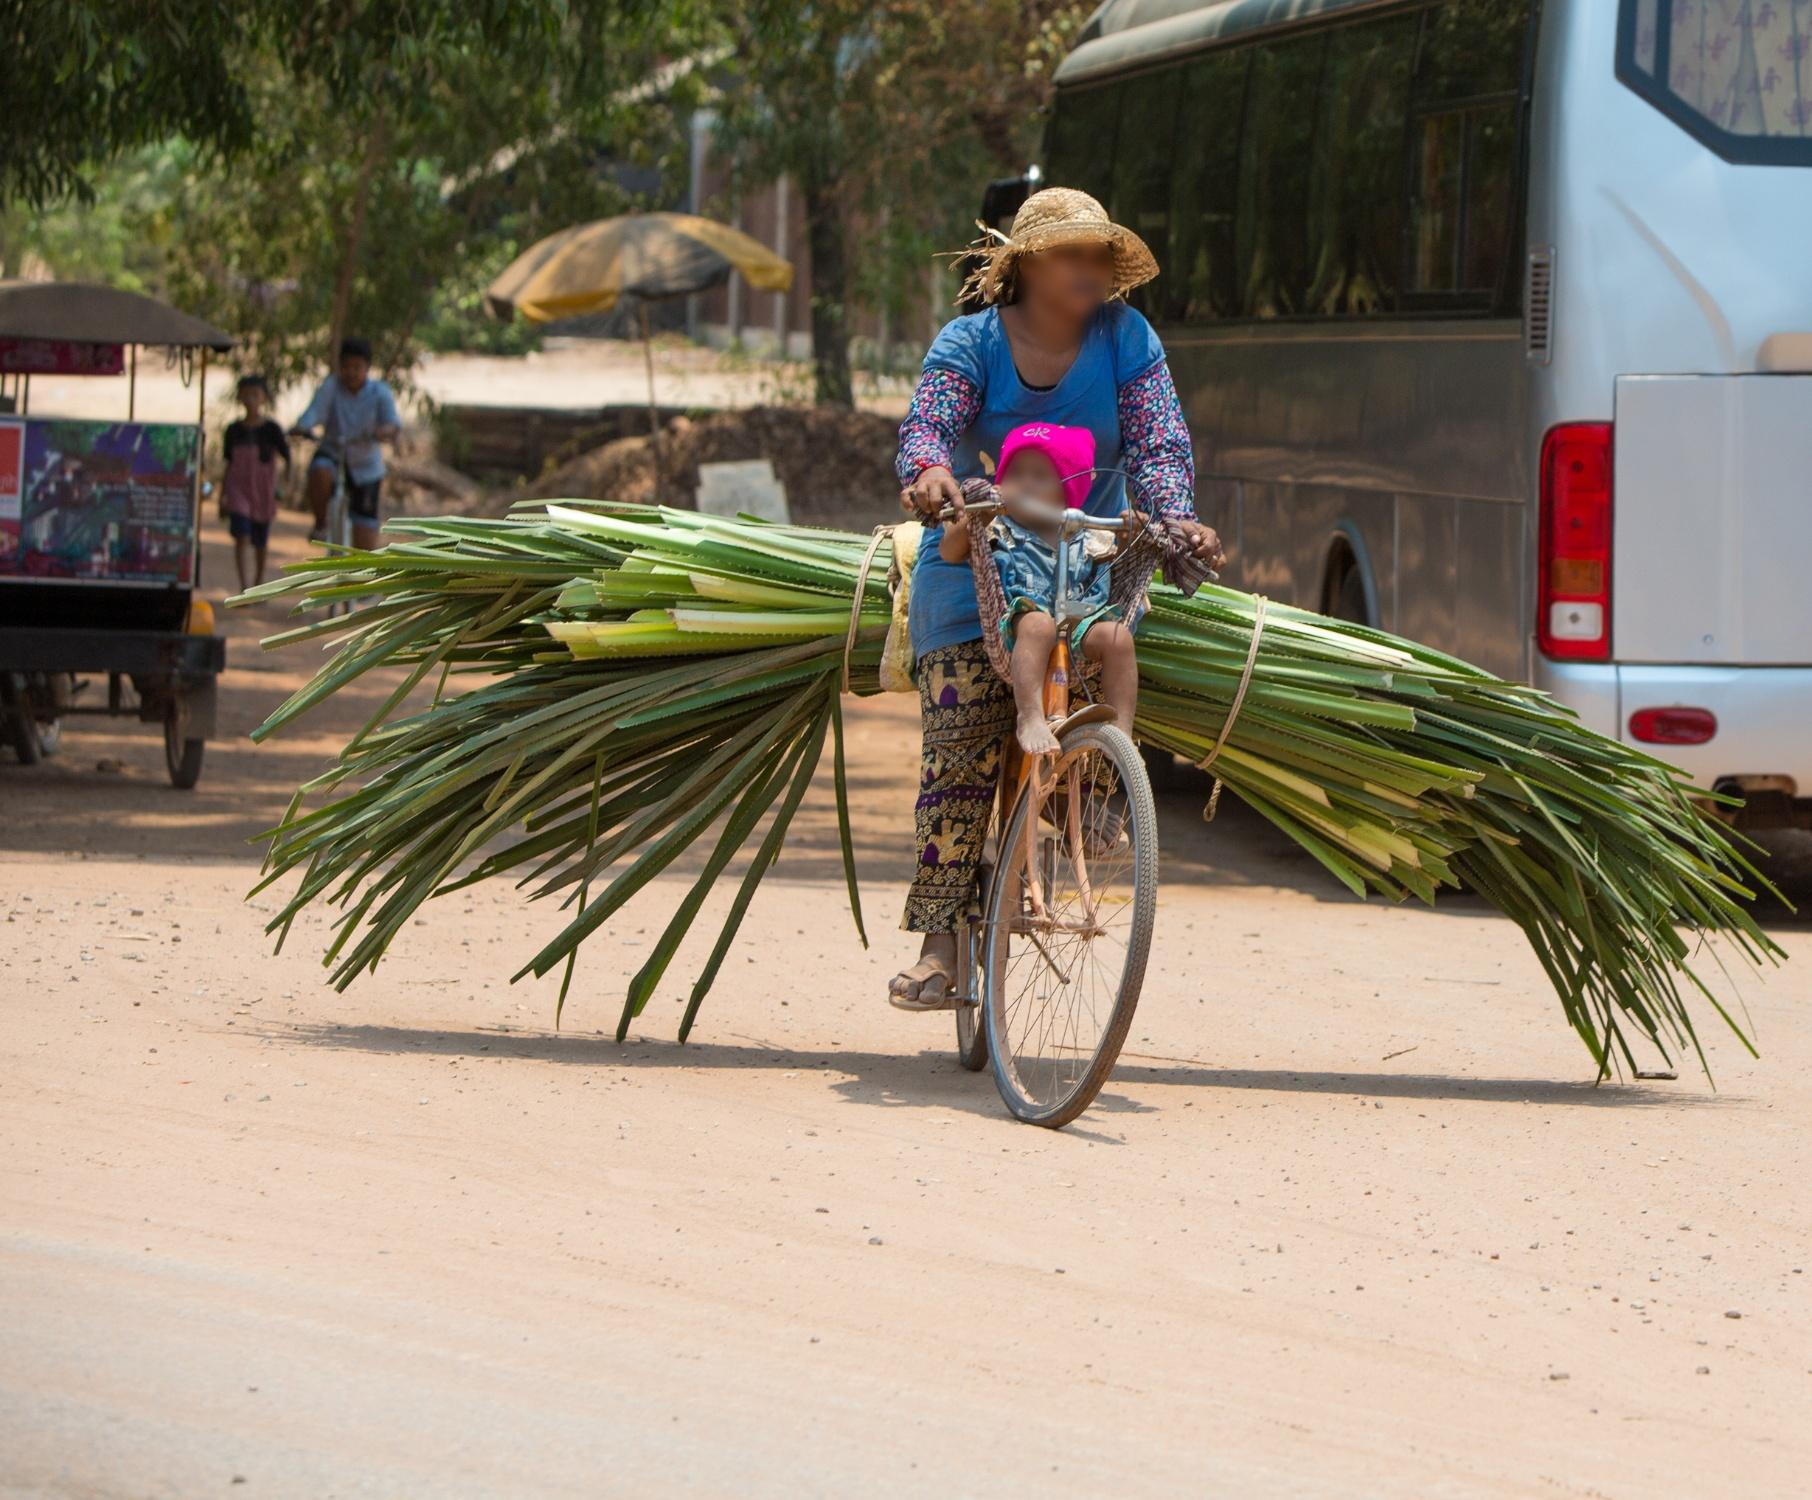Can you describe the significance of the objects the woman is transporting? The woman is transporting a large bundle of green palm leaves secured to the back of her bicycle. Palm leaves can be highly versatile and frequently used for various purposes in rural and agricultural settings. They may be used for thatching roofs, weaving baskets or mats, and even as fodder for livestock. The sight of her transporting these leaves could signify her involvement in local crafts, agricultural activities, or small-scale commerce. This scene highlights the resourcefulness and industrious spirit common in rural communities, where natural materials are utilized effectively in everyday life. What else do you notice about the environment around the woman? The environment around the woman is distinctly rural, indicated by the unpaved dirt road she is traveling on. In the background, there is a white bus parked, suggesting a connection to nearby transportation routes, possibly indicating a local hub or a marketplace. Additionally, a few people can be seen walking in the distance, which implies that the area is a communal space with regular foot traffic. The presence of trees scattered around adds to the rural ambiance, and the clear blue sky overhead suggests a sunny and possibly warm day. The blending of natural elements with man-made structures reflects a harmonious coexistence often found in rural communities. Imagine a fantastical event happening in this scene. What do you envision? In a fantastical twist, imagine the large bundle of palm leaves on the woman's bicycle beginning to shimmer with a magical light. The leaves start to flutter and lift, transforming into vibrant, colorful wings. The bicycle, too, begins to change, its wheels morphing into celestial orbs that hover above the ground. The woman, now ethereal with an aura of magic around her, ascends into the sky, riding a magnificent flying bicycle, her straw hat glowing with radiant patterns. As she soars over the village, her path leaves a trail of sparkling stars, blessing the land below with enchantment and prosperity. The people around pause in awe, witnessing this extraordinary event that turns an ordinary moment into a tale of wonder and magic. 